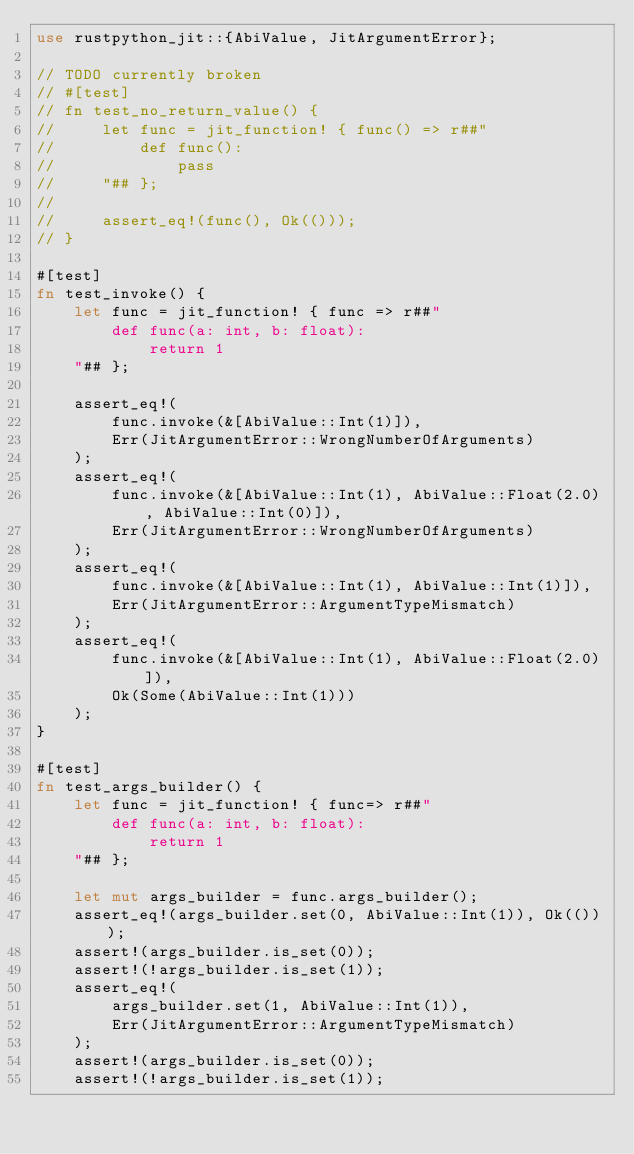Convert code to text. <code><loc_0><loc_0><loc_500><loc_500><_Rust_>use rustpython_jit::{AbiValue, JitArgumentError};

// TODO currently broken
// #[test]
// fn test_no_return_value() {
//     let func = jit_function! { func() => r##"
//         def func():
//             pass
//     "## };
//
//     assert_eq!(func(), Ok(()));
// }

#[test]
fn test_invoke() {
    let func = jit_function! { func => r##"
        def func(a: int, b: float):
            return 1
    "## };

    assert_eq!(
        func.invoke(&[AbiValue::Int(1)]),
        Err(JitArgumentError::WrongNumberOfArguments)
    );
    assert_eq!(
        func.invoke(&[AbiValue::Int(1), AbiValue::Float(2.0), AbiValue::Int(0)]),
        Err(JitArgumentError::WrongNumberOfArguments)
    );
    assert_eq!(
        func.invoke(&[AbiValue::Int(1), AbiValue::Int(1)]),
        Err(JitArgumentError::ArgumentTypeMismatch)
    );
    assert_eq!(
        func.invoke(&[AbiValue::Int(1), AbiValue::Float(2.0)]),
        Ok(Some(AbiValue::Int(1)))
    );
}

#[test]
fn test_args_builder() {
    let func = jit_function! { func=> r##"
        def func(a: int, b: float):
            return 1
    "## };

    let mut args_builder = func.args_builder();
    assert_eq!(args_builder.set(0, AbiValue::Int(1)), Ok(()));
    assert!(args_builder.is_set(0));
    assert!(!args_builder.is_set(1));
    assert_eq!(
        args_builder.set(1, AbiValue::Int(1)),
        Err(JitArgumentError::ArgumentTypeMismatch)
    );
    assert!(args_builder.is_set(0));
    assert!(!args_builder.is_set(1));</code> 